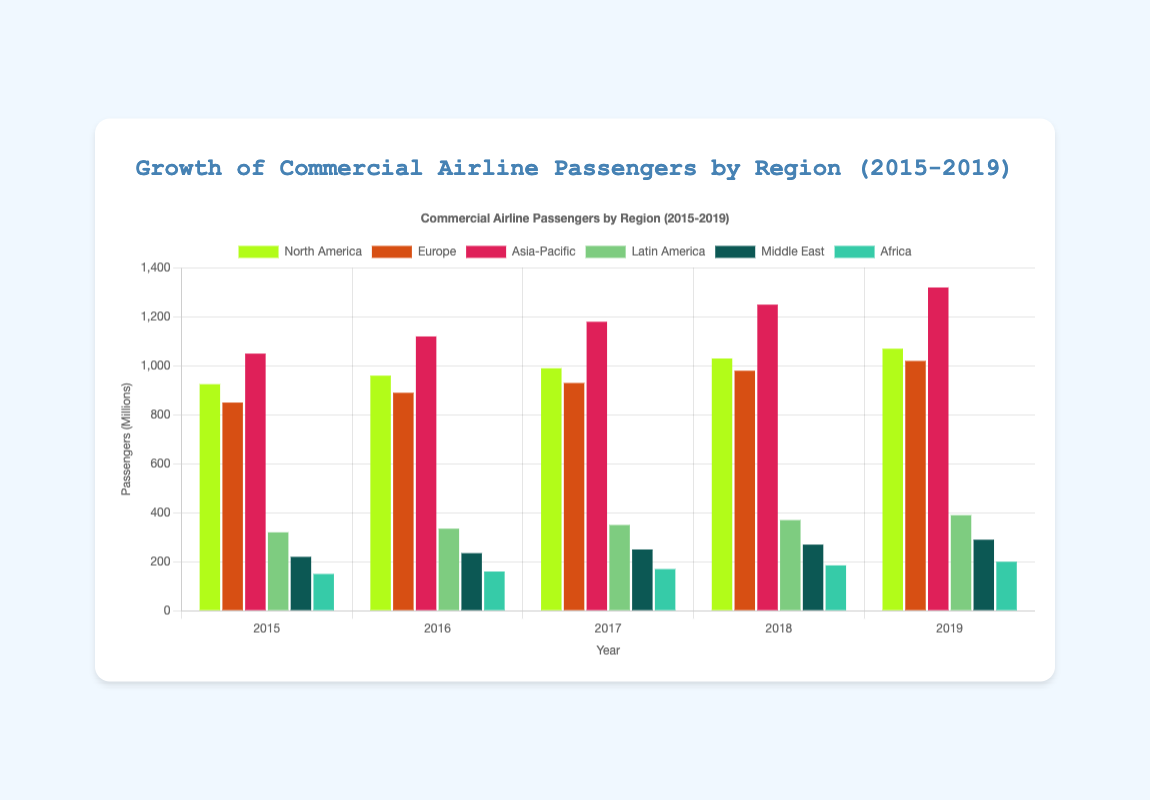Which region had the highest number of passengers in 2019? Observe the heights of the bars in the 2019 group. The Asia-Pacific bar is the tallest.
Answer: Asia-Pacific Compare the growth in the number of passengers from 2015 to 2019 between North America and Europe. Compute the difference in passengers for each region: North America (1070M - 925M = 145M), Europe (1020M - 850M = 170M). Europe has a larger increase.
Answer: Europe What is the total number of passengers in 2015 across all regions? Sum the passenger numbers for each region in 2015: 925M (North America) + 850M (Europe) + 1050M (Asia-Pacific) + 320M (Latin America) + 220M (Middle East) + 150M (Africa) = 3515M.
Answer: 3515M Which year had the lowest number of passengers in Africa? Compare the heights of the orange bars for Africa across years. The 2015 bar is the lowest.
Answer: 2015 What is the average yearly increase in the number of passengers in the Middle East from 2015 to 2019? Calculate the difference between 2019 and 2015, then divide by the number of years: (290M - 220M) / 4 = 70M / 4 = 17.5M.
Answer: 17.5M Did Latin America have a consistent increase in passengers every year from 2015 to 2019? Observe the heights of the Latin America bars year by year. Each subsequent bar is higher than the previous one, indicating consistent growth.
Answer: Yes Which region experienced the largest growth in the number of passengers from 2015 to 2019? Compute the difference for each region: Asia-Pacific (1320M - 1050M = 270M), North America (1070M - 925M = 145M), Europe (1020M - 850M = 170M), Latin America (390M - 320M = 70M), Middle East (290M - 220M = 70M), Africa (200M - 150M = 50M). The Asia-Pacific region had the highest increase.
Answer: Asia-Pacific Compare the number of passengers in Asia-Pacific in 2017 to the number in North America and Europe combined in the same year. Asia-Pacific in 2017 had 1180M passengers. North America had 990M and Europe had 930M in 2017, combined is 1920M. Asia-Pacific's number is lower.
Answer: North America and Europe combined By how much did the number of passengers in Europe increase from 2017 to 2018? Subtract the number of passengers in 2017 from that in 2018 for Europe: 980M - 930M = 50M.
Answer: 50M 